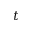Convert formula to latex. <formula><loc_0><loc_0><loc_500><loc_500>t</formula> 